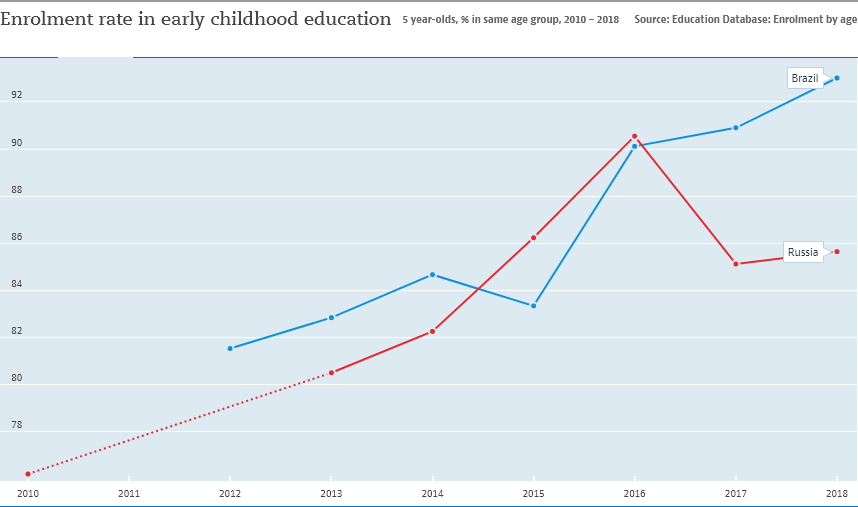Identify some key points in this picture. In 2016, the enrollment rate in early childhood education in Russia reached its highest level. Brazil is represented by the blue color line. 